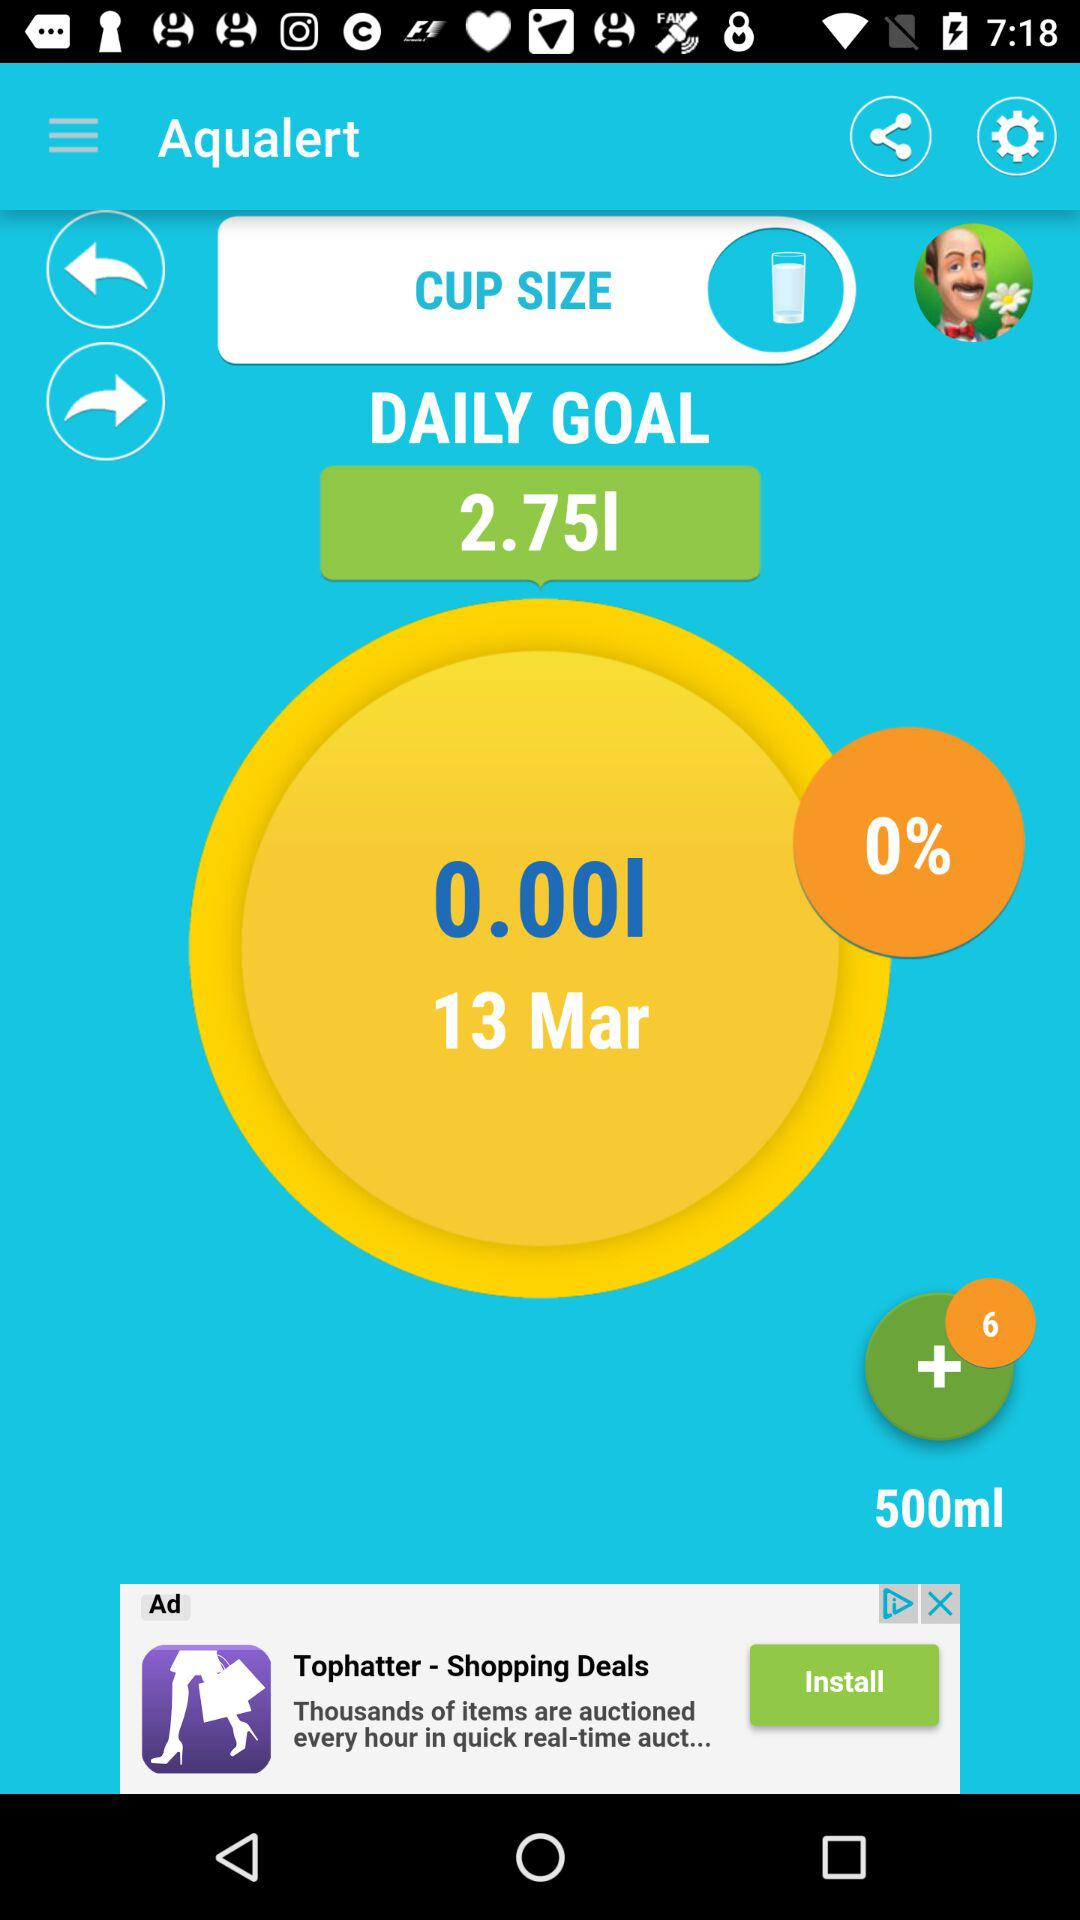What is the percent of water consumed?
Answer the question using a single word or phrase. 0% 